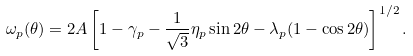<formula> <loc_0><loc_0><loc_500><loc_500>\omega _ { p } ( \theta ) = 2 A \left [ 1 - \gamma _ { p } - \frac { 1 } { \sqrt { 3 } } \eta _ { p } \sin 2 \theta - \lambda _ { p } ( 1 - \cos 2 \theta ) \right ] ^ { 1 / 2 } .</formula> 